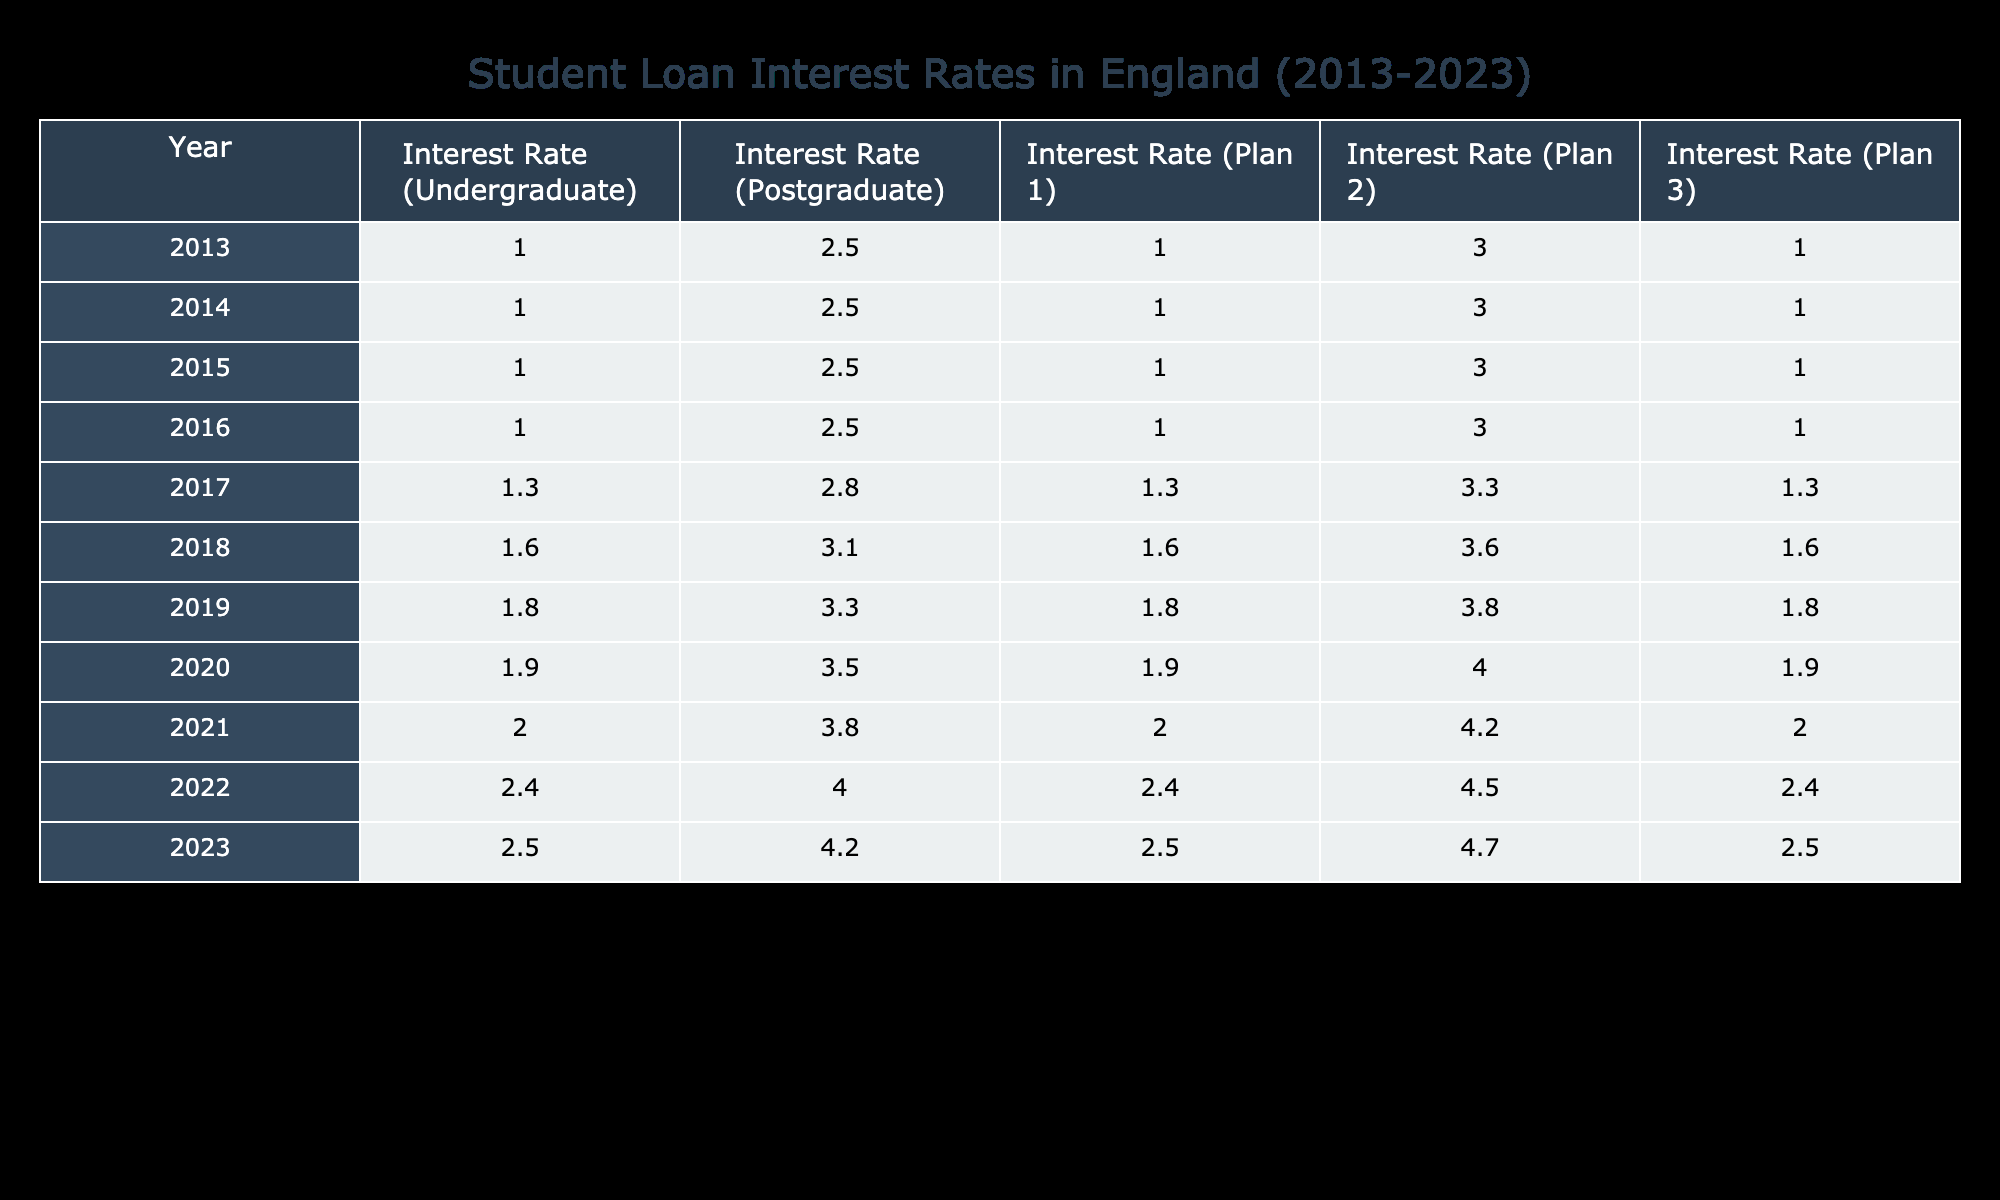What was the interest rate for undergraduate loans in 2016? Referring to the table, the interest rate for undergraduate loans in 2016 is listed under the appropriate year. It shows that the rate was 1.0.
Answer: 1.0 In which year did the interest rate for postgraduate loans first exceed 3.0? Looking at the table, the interest rate for postgraduate loans is compared year by year. It first exceeds 3.0 in the year 2017, when it is 2.8, and subsequently increases each year thereafter.
Answer: 2017 What is the average interest rate for Plan 1 from 2013 to 2023? To find the average interest rate for Plan 1, add the interest rates for each year (1.0 + 1.0 + 1.0 + 1.0 + 1.3 + 1.6 + 1.8 + 1.9 + 2.0 + 2.4 + 2.5) = 16.5. Then divide by the number of years (11) to get 16.5/11 = 1.5.
Answer: 1.5 Was the interest rate for Plan 2 lower than 4.0 in 2021? Referring to the table, the interest rate for Plan 2 in 2021 is listed as 4.2, which is higher than 4.0. Thus the statement is false.
Answer: No What was the trend of interest rates for undergraduate loans from 2013 to 2023? Analyzing the table, the interest rates for undergraduate loans start at 1.0 in 2013 and increase gradually each year, reaching 2.5 in 2023. This indicates a general upward trend over the decade.
Answer: Increasing trend In which year was the gap between postgraduate and Plan 3 interest rates the largest? By examining the table, we look at the differences between the postgraduate and Plan 3 interest rates for each year. The largest gap occurs in 2022 with postgraduate at 4.0 and Plan 3 at 2.4, yielding a difference of 1.6.
Answer: 2022 What is the maximum interest rate for postgraduate loans from 2013 to 2023? Looking at the table, the highest value for postgraduate loans is found under the relevant year. The maximum interest rate reached is 4.2 in 2023.
Answer: 4.2 How much did the interest rate for Plan 1 increase from 2015 to 2023? To calculate the increase, we subtract the Plan 1 interest rate in 2015 (1.0) from that in 2023 (2.5). Therefore, 2.5 - 1.0 = 1.5. The interest rate increased by 1.5.
Answer: 1.5 